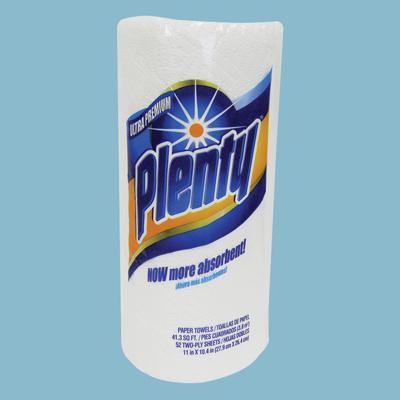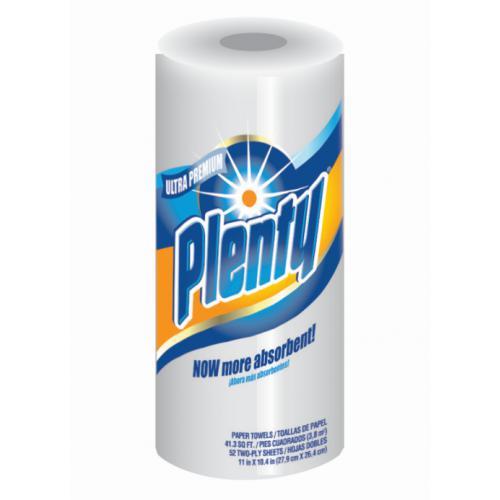The first image is the image on the left, the second image is the image on the right. Assess this claim about the two images: "Two individually wrapped rolls of paper towels are both standing upright and have similar brand labels, but are shown with different background colors.". Correct or not? Answer yes or no. Yes. The first image is the image on the left, the second image is the image on the right. Evaluate the accuracy of this statement regarding the images: "Each image shows an individually-wrapped single roll of paper towels, and left and right packages have the same sunburst logo on front.". Is it true? Answer yes or no. Yes. 